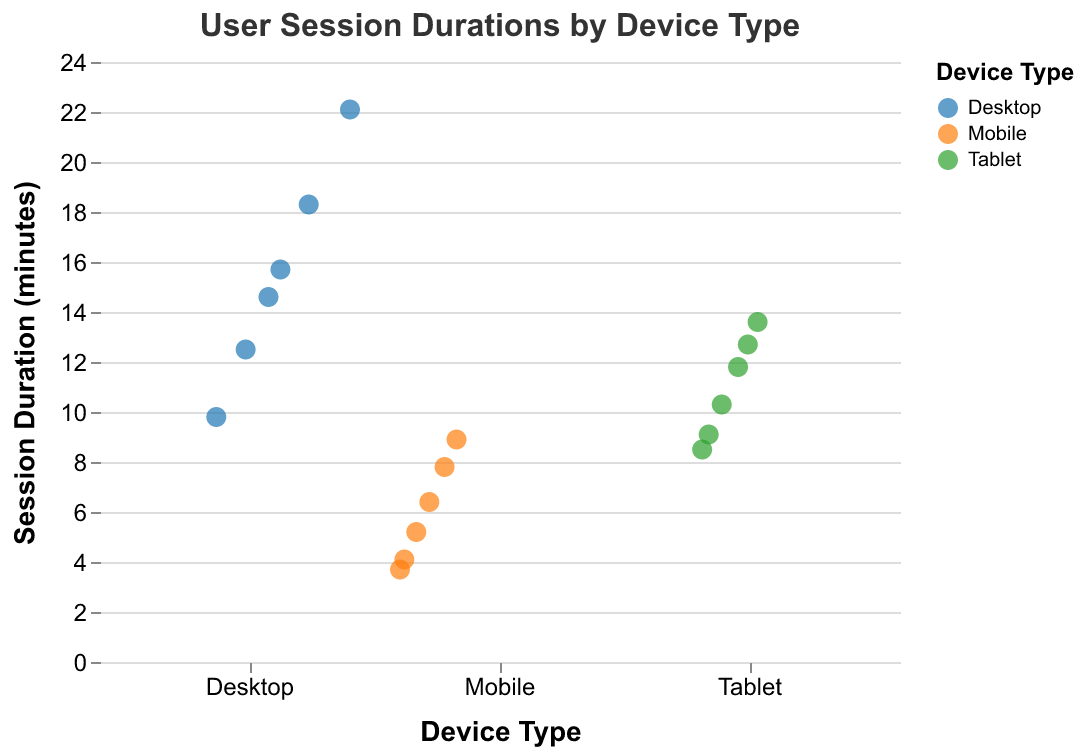What is the title of the plot? The title of the plot is displayed at the top, indicating the content of the visualization.
Answer: User Session Durations by Device Type How many device types are shown in the plot? There are three distinct categories on the x-axis representing different device types.
Answer: Three (Desktop, Mobile, Tablet) Which device type has the highest single session duration? By examining the y-axis for the maximum data point and correlating it to the x-axis category, we can identify the device type with the highest session duration.
Answer: Desktop What is the average session duration for mobile devices? Add up all session durations for mobile devices and divide by the number of mobile data points. Calculation: (5.2 + 8.9 + 3.7 + 6.4 + 4.1 + 7.8)/6 = 36.1/6
Answer: 6.02 Compare the range of session durations between desktop and tablet. Check the highest and lowest session duration values for both device types on the y-axis, then calculate the range (max - min). Desktop range: 22.1 - 9.8 = 12.3. Tablet range: 13.6 - 8.5 = 5.1
Answer: Desktop: 12.3, Tablet: 5.1 Which device type shows more consistency in user session durations? Consistency can be assessed by the spread of the points along the y-axis. The tighter the cluster, the more consistent.
Answer: Tablet Are there any session durations for desktop less than the highest session duration for mobile? Compare the highest session duration for mobile (8.9) to each desktop session duration.
Answer: Yes Which device type has the lowest average session duration? Calculate the average session duration for each device type, then compare them. Mobile: (5.2 + 8.9 + 3.7 + 6.4 + 4.1 + 7.8)/6 = 6.02. Desktop: (12.5 + 18.3 + 15.7 + 22.1 + 9.8 + 14.6)/6 = 15.5. Tablet: (10.3 + 13.6 + 9.1 + 11.8 + 8.5 + 12.7)/6 = 11
Answer: Mobile Which device type shows the widest range of session durations? Calculate the range of session durations for each device type and identify the largest one. Desktop range: 22.1 - 9.8 = 12.3. Mobile range: 8.9 - 3.7 = 5.2. Tablet range: 13.6 - 8.5 = 5.1
Answer: Desktop 